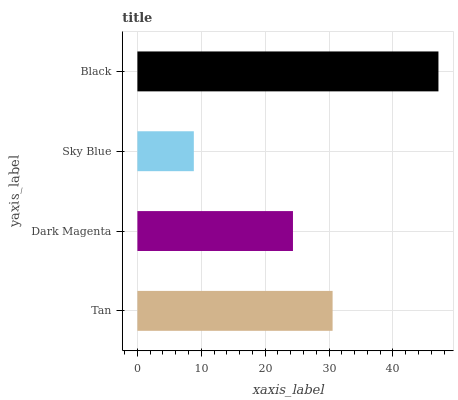Is Sky Blue the minimum?
Answer yes or no. Yes. Is Black the maximum?
Answer yes or no. Yes. Is Dark Magenta the minimum?
Answer yes or no. No. Is Dark Magenta the maximum?
Answer yes or no. No. Is Tan greater than Dark Magenta?
Answer yes or no. Yes. Is Dark Magenta less than Tan?
Answer yes or no. Yes. Is Dark Magenta greater than Tan?
Answer yes or no. No. Is Tan less than Dark Magenta?
Answer yes or no. No. Is Tan the high median?
Answer yes or no. Yes. Is Dark Magenta the low median?
Answer yes or no. Yes. Is Black the high median?
Answer yes or no. No. Is Black the low median?
Answer yes or no. No. 